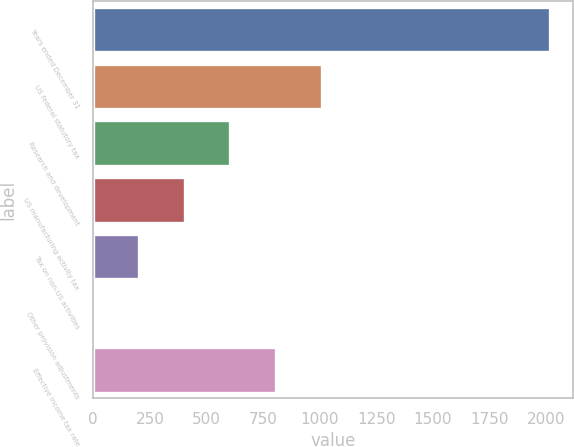<chart> <loc_0><loc_0><loc_500><loc_500><bar_chart><fcel>Years ended December 31<fcel>US federal statutory tax<fcel>Research and development<fcel>US manufacturing activity tax<fcel>Tax on non-US activities<fcel>Other provision adjustments<fcel>Effective income tax rate<nl><fcel>2017<fcel>1008.6<fcel>605.24<fcel>403.56<fcel>201.88<fcel>0.2<fcel>806.92<nl></chart> 